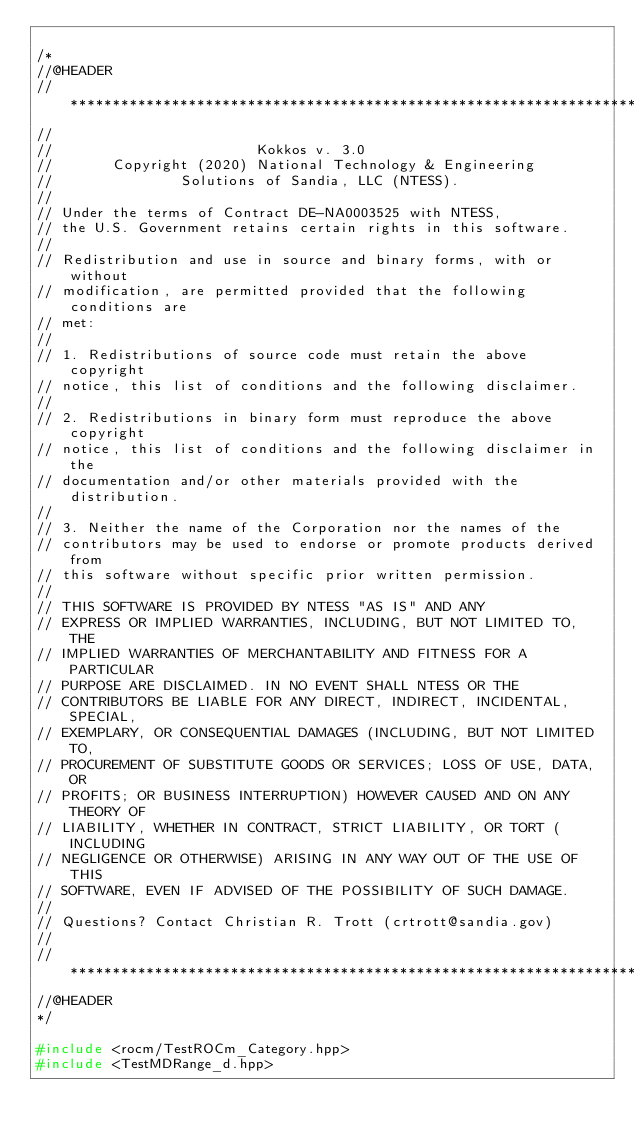Convert code to text. <code><loc_0><loc_0><loc_500><loc_500><_C++_>
/*
//@HEADER
// ************************************************************************
//
//                        Kokkos v. 3.0
//       Copyright (2020) National Technology & Engineering
//               Solutions of Sandia, LLC (NTESS).
//
// Under the terms of Contract DE-NA0003525 with NTESS,
// the U.S. Government retains certain rights in this software.
//
// Redistribution and use in source and binary forms, with or without
// modification, are permitted provided that the following conditions are
// met:
//
// 1. Redistributions of source code must retain the above copyright
// notice, this list of conditions and the following disclaimer.
//
// 2. Redistributions in binary form must reproduce the above copyright
// notice, this list of conditions and the following disclaimer in the
// documentation and/or other materials provided with the distribution.
//
// 3. Neither the name of the Corporation nor the names of the
// contributors may be used to endorse or promote products derived from
// this software without specific prior written permission.
//
// THIS SOFTWARE IS PROVIDED BY NTESS "AS IS" AND ANY
// EXPRESS OR IMPLIED WARRANTIES, INCLUDING, BUT NOT LIMITED TO, THE
// IMPLIED WARRANTIES OF MERCHANTABILITY AND FITNESS FOR A PARTICULAR
// PURPOSE ARE DISCLAIMED. IN NO EVENT SHALL NTESS OR THE
// CONTRIBUTORS BE LIABLE FOR ANY DIRECT, INDIRECT, INCIDENTAL, SPECIAL,
// EXEMPLARY, OR CONSEQUENTIAL DAMAGES (INCLUDING, BUT NOT LIMITED TO,
// PROCUREMENT OF SUBSTITUTE GOODS OR SERVICES; LOSS OF USE, DATA, OR
// PROFITS; OR BUSINESS INTERRUPTION) HOWEVER CAUSED AND ON ANY THEORY OF
// LIABILITY, WHETHER IN CONTRACT, STRICT LIABILITY, OR TORT (INCLUDING
// NEGLIGENCE OR OTHERWISE) ARISING IN ANY WAY OUT OF THE USE OF THIS
// SOFTWARE, EVEN IF ADVISED OF THE POSSIBILITY OF SUCH DAMAGE.
//
// Questions? Contact Christian R. Trott (crtrott@sandia.gov)
//
// ************************************************************************
//@HEADER
*/

#include <rocm/TestROCm_Category.hpp>
#include <TestMDRange_d.hpp>
</code> 